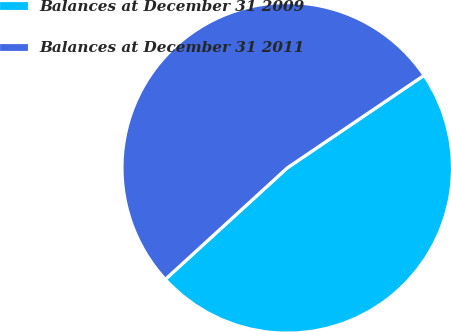Convert chart. <chart><loc_0><loc_0><loc_500><loc_500><pie_chart><fcel>Balances at December 31 2009<fcel>Balances at December 31 2011<nl><fcel>47.68%<fcel>52.32%<nl></chart> 